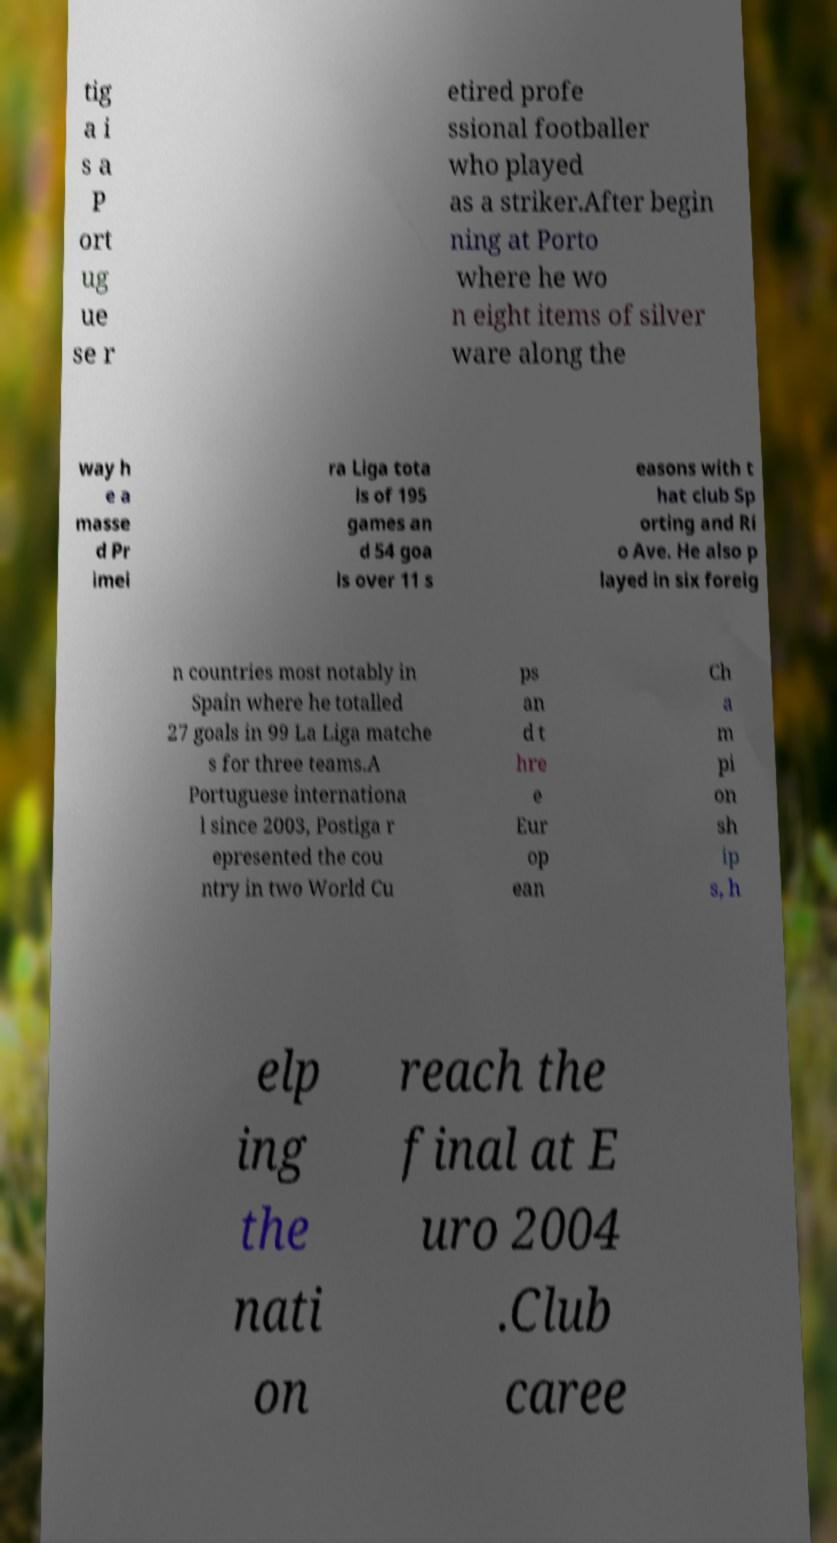Can you read and provide the text displayed in the image?This photo seems to have some interesting text. Can you extract and type it out for me? tig a i s a P ort ug ue se r etired profe ssional footballer who played as a striker.After begin ning at Porto where he wo n eight items of silver ware along the way h e a masse d Pr imei ra Liga tota ls of 195 games an d 54 goa ls over 11 s easons with t hat club Sp orting and Ri o Ave. He also p layed in six foreig n countries most notably in Spain where he totalled 27 goals in 99 La Liga matche s for three teams.A Portuguese internationa l since 2003, Postiga r epresented the cou ntry in two World Cu ps an d t hre e Eur op ean Ch a m pi on sh ip s, h elp ing the nati on reach the final at E uro 2004 .Club caree 